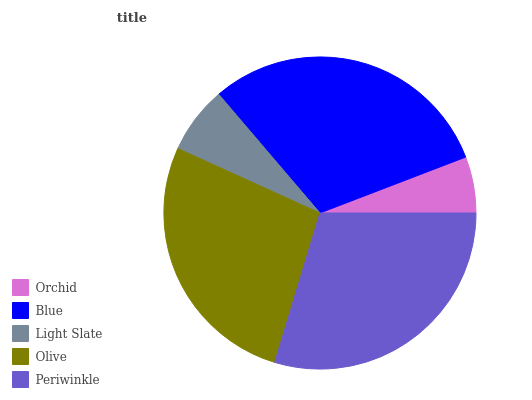Is Orchid the minimum?
Answer yes or no. Yes. Is Blue the maximum?
Answer yes or no. Yes. Is Light Slate the minimum?
Answer yes or no. No. Is Light Slate the maximum?
Answer yes or no. No. Is Blue greater than Light Slate?
Answer yes or no. Yes. Is Light Slate less than Blue?
Answer yes or no. Yes. Is Light Slate greater than Blue?
Answer yes or no. No. Is Blue less than Light Slate?
Answer yes or no. No. Is Olive the high median?
Answer yes or no. Yes. Is Olive the low median?
Answer yes or no. Yes. Is Orchid the high median?
Answer yes or no. No. Is Orchid the low median?
Answer yes or no. No. 